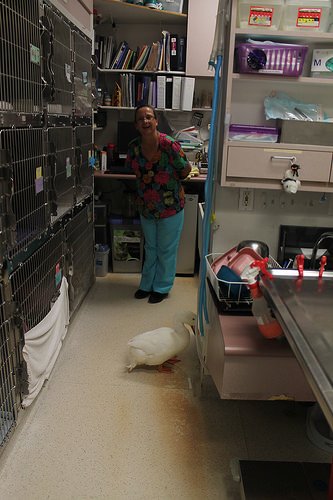<image>
Is the lady in front of the duck? No. The lady is not in front of the duck. The spatial positioning shows a different relationship between these objects. 